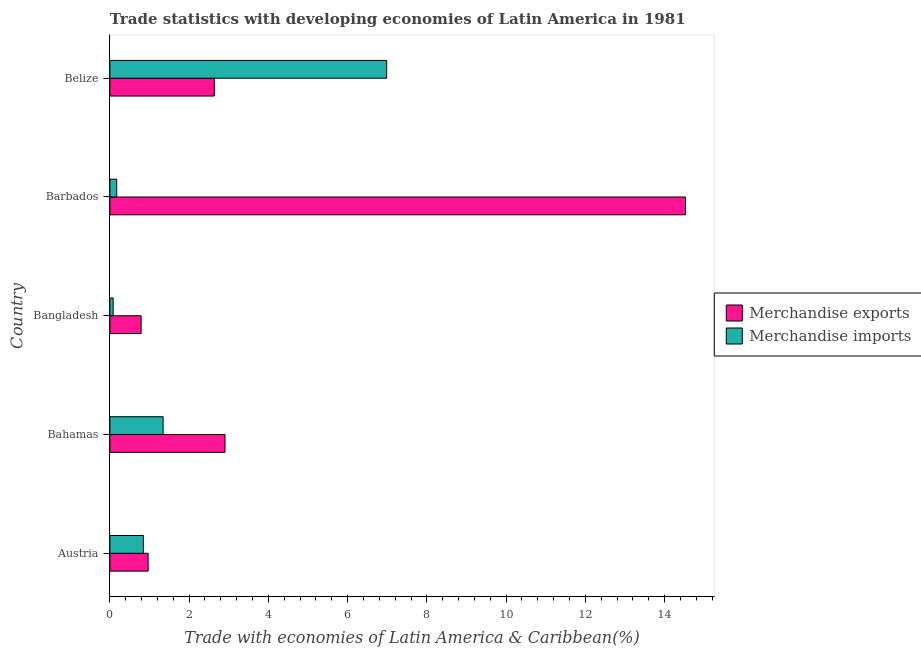How many groups of bars are there?
Make the answer very short. 5. How many bars are there on the 5th tick from the bottom?
Ensure brevity in your answer.  2. What is the label of the 1st group of bars from the top?
Provide a succinct answer. Belize. What is the merchandise imports in Bahamas?
Keep it short and to the point. 1.34. Across all countries, what is the maximum merchandise imports?
Offer a very short reply. 6.99. Across all countries, what is the minimum merchandise exports?
Keep it short and to the point. 0.79. In which country was the merchandise exports maximum?
Offer a very short reply. Barbados. In which country was the merchandise imports minimum?
Give a very brief answer. Bangladesh. What is the total merchandise exports in the graph?
Your answer should be compact. 21.82. What is the difference between the merchandise imports in Bahamas and that in Barbados?
Your answer should be very brief. 1.17. What is the difference between the merchandise exports in Bahamas and the merchandise imports in Barbados?
Provide a short and direct response. 2.73. What is the average merchandise exports per country?
Make the answer very short. 4.37. What is the difference between the merchandise exports and merchandise imports in Bangladesh?
Make the answer very short. 0.71. What is the ratio of the merchandise imports in Austria to that in Bangladesh?
Give a very brief answer. 10.26. What is the difference between the highest and the second highest merchandise exports?
Provide a short and direct response. 11.62. What is the difference between the highest and the lowest merchandise exports?
Your response must be concise. 13.74. Are all the bars in the graph horizontal?
Your answer should be compact. Yes. What is the difference between two consecutive major ticks on the X-axis?
Offer a terse response. 2. How many legend labels are there?
Keep it short and to the point. 2. What is the title of the graph?
Offer a terse response. Trade statistics with developing economies of Latin America in 1981. What is the label or title of the X-axis?
Your response must be concise. Trade with economies of Latin America & Caribbean(%). What is the label or title of the Y-axis?
Keep it short and to the point. Country. What is the Trade with economies of Latin America & Caribbean(%) of Merchandise exports in Austria?
Give a very brief answer. 0.97. What is the Trade with economies of Latin America & Caribbean(%) of Merchandise imports in Austria?
Your answer should be compact. 0.85. What is the Trade with economies of Latin America & Caribbean(%) in Merchandise exports in Bahamas?
Your answer should be compact. 2.91. What is the Trade with economies of Latin America & Caribbean(%) of Merchandise imports in Bahamas?
Your answer should be very brief. 1.34. What is the Trade with economies of Latin America & Caribbean(%) of Merchandise exports in Bangladesh?
Make the answer very short. 0.79. What is the Trade with economies of Latin America & Caribbean(%) of Merchandise imports in Bangladesh?
Give a very brief answer. 0.08. What is the Trade with economies of Latin America & Caribbean(%) of Merchandise exports in Barbados?
Your answer should be compact. 14.53. What is the Trade with economies of Latin America & Caribbean(%) in Merchandise imports in Barbados?
Provide a succinct answer. 0.17. What is the Trade with economies of Latin America & Caribbean(%) of Merchandise exports in Belize?
Keep it short and to the point. 2.63. What is the Trade with economies of Latin America & Caribbean(%) in Merchandise imports in Belize?
Offer a very short reply. 6.99. Across all countries, what is the maximum Trade with economies of Latin America & Caribbean(%) of Merchandise exports?
Offer a terse response. 14.53. Across all countries, what is the maximum Trade with economies of Latin America & Caribbean(%) in Merchandise imports?
Keep it short and to the point. 6.99. Across all countries, what is the minimum Trade with economies of Latin America & Caribbean(%) of Merchandise exports?
Give a very brief answer. 0.79. Across all countries, what is the minimum Trade with economies of Latin America & Caribbean(%) of Merchandise imports?
Make the answer very short. 0.08. What is the total Trade with economies of Latin America & Caribbean(%) in Merchandise exports in the graph?
Offer a very short reply. 21.82. What is the total Trade with economies of Latin America & Caribbean(%) of Merchandise imports in the graph?
Provide a short and direct response. 9.43. What is the difference between the Trade with economies of Latin America & Caribbean(%) in Merchandise exports in Austria and that in Bahamas?
Give a very brief answer. -1.94. What is the difference between the Trade with economies of Latin America & Caribbean(%) in Merchandise imports in Austria and that in Bahamas?
Give a very brief answer. -0.5. What is the difference between the Trade with economies of Latin America & Caribbean(%) of Merchandise exports in Austria and that in Bangladesh?
Make the answer very short. 0.18. What is the difference between the Trade with economies of Latin America & Caribbean(%) in Merchandise imports in Austria and that in Bangladesh?
Keep it short and to the point. 0.76. What is the difference between the Trade with economies of Latin America & Caribbean(%) of Merchandise exports in Austria and that in Barbados?
Keep it short and to the point. -13.56. What is the difference between the Trade with economies of Latin America & Caribbean(%) of Merchandise imports in Austria and that in Barbados?
Offer a terse response. 0.67. What is the difference between the Trade with economies of Latin America & Caribbean(%) in Merchandise exports in Austria and that in Belize?
Your response must be concise. -1.67. What is the difference between the Trade with economies of Latin America & Caribbean(%) in Merchandise imports in Austria and that in Belize?
Offer a very short reply. -6.14. What is the difference between the Trade with economies of Latin America & Caribbean(%) of Merchandise exports in Bahamas and that in Bangladesh?
Offer a terse response. 2.12. What is the difference between the Trade with economies of Latin America & Caribbean(%) of Merchandise imports in Bahamas and that in Bangladesh?
Give a very brief answer. 1.26. What is the difference between the Trade with economies of Latin America & Caribbean(%) of Merchandise exports in Bahamas and that in Barbados?
Keep it short and to the point. -11.62. What is the difference between the Trade with economies of Latin America & Caribbean(%) of Merchandise imports in Bahamas and that in Barbados?
Provide a succinct answer. 1.17. What is the difference between the Trade with economies of Latin America & Caribbean(%) of Merchandise exports in Bahamas and that in Belize?
Offer a very short reply. 0.27. What is the difference between the Trade with economies of Latin America & Caribbean(%) of Merchandise imports in Bahamas and that in Belize?
Keep it short and to the point. -5.64. What is the difference between the Trade with economies of Latin America & Caribbean(%) of Merchandise exports in Bangladesh and that in Barbados?
Provide a short and direct response. -13.74. What is the difference between the Trade with economies of Latin America & Caribbean(%) of Merchandise imports in Bangladesh and that in Barbados?
Your answer should be compact. -0.09. What is the difference between the Trade with economies of Latin America & Caribbean(%) of Merchandise exports in Bangladesh and that in Belize?
Offer a very short reply. -1.85. What is the difference between the Trade with economies of Latin America & Caribbean(%) in Merchandise imports in Bangladesh and that in Belize?
Provide a succinct answer. -6.9. What is the difference between the Trade with economies of Latin America & Caribbean(%) in Merchandise exports in Barbados and that in Belize?
Your answer should be compact. 11.89. What is the difference between the Trade with economies of Latin America & Caribbean(%) in Merchandise imports in Barbados and that in Belize?
Offer a very short reply. -6.81. What is the difference between the Trade with economies of Latin America & Caribbean(%) of Merchandise exports in Austria and the Trade with economies of Latin America & Caribbean(%) of Merchandise imports in Bahamas?
Provide a short and direct response. -0.38. What is the difference between the Trade with economies of Latin America & Caribbean(%) of Merchandise exports in Austria and the Trade with economies of Latin America & Caribbean(%) of Merchandise imports in Bangladesh?
Provide a succinct answer. 0.88. What is the difference between the Trade with economies of Latin America & Caribbean(%) of Merchandise exports in Austria and the Trade with economies of Latin America & Caribbean(%) of Merchandise imports in Barbados?
Offer a terse response. 0.79. What is the difference between the Trade with economies of Latin America & Caribbean(%) of Merchandise exports in Austria and the Trade with economies of Latin America & Caribbean(%) of Merchandise imports in Belize?
Keep it short and to the point. -6.02. What is the difference between the Trade with economies of Latin America & Caribbean(%) of Merchandise exports in Bahamas and the Trade with economies of Latin America & Caribbean(%) of Merchandise imports in Bangladesh?
Keep it short and to the point. 2.82. What is the difference between the Trade with economies of Latin America & Caribbean(%) in Merchandise exports in Bahamas and the Trade with economies of Latin America & Caribbean(%) in Merchandise imports in Barbados?
Ensure brevity in your answer.  2.73. What is the difference between the Trade with economies of Latin America & Caribbean(%) in Merchandise exports in Bahamas and the Trade with economies of Latin America & Caribbean(%) in Merchandise imports in Belize?
Offer a very short reply. -4.08. What is the difference between the Trade with economies of Latin America & Caribbean(%) in Merchandise exports in Bangladesh and the Trade with economies of Latin America & Caribbean(%) in Merchandise imports in Barbados?
Offer a terse response. 0.62. What is the difference between the Trade with economies of Latin America & Caribbean(%) of Merchandise exports in Bangladesh and the Trade with economies of Latin America & Caribbean(%) of Merchandise imports in Belize?
Offer a terse response. -6.2. What is the difference between the Trade with economies of Latin America & Caribbean(%) of Merchandise exports in Barbados and the Trade with economies of Latin America & Caribbean(%) of Merchandise imports in Belize?
Provide a succinct answer. 7.54. What is the average Trade with economies of Latin America & Caribbean(%) in Merchandise exports per country?
Offer a terse response. 4.36. What is the average Trade with economies of Latin America & Caribbean(%) of Merchandise imports per country?
Offer a terse response. 1.89. What is the difference between the Trade with economies of Latin America & Caribbean(%) of Merchandise exports and Trade with economies of Latin America & Caribbean(%) of Merchandise imports in Austria?
Your answer should be very brief. 0.12. What is the difference between the Trade with economies of Latin America & Caribbean(%) in Merchandise exports and Trade with economies of Latin America & Caribbean(%) in Merchandise imports in Bahamas?
Offer a terse response. 1.56. What is the difference between the Trade with economies of Latin America & Caribbean(%) of Merchandise exports and Trade with economies of Latin America & Caribbean(%) of Merchandise imports in Bangladesh?
Give a very brief answer. 0.71. What is the difference between the Trade with economies of Latin America & Caribbean(%) of Merchandise exports and Trade with economies of Latin America & Caribbean(%) of Merchandise imports in Barbados?
Provide a short and direct response. 14.36. What is the difference between the Trade with economies of Latin America & Caribbean(%) in Merchandise exports and Trade with economies of Latin America & Caribbean(%) in Merchandise imports in Belize?
Ensure brevity in your answer.  -4.35. What is the ratio of the Trade with economies of Latin America & Caribbean(%) in Merchandise exports in Austria to that in Bahamas?
Make the answer very short. 0.33. What is the ratio of the Trade with economies of Latin America & Caribbean(%) in Merchandise imports in Austria to that in Bahamas?
Your response must be concise. 0.63. What is the ratio of the Trade with economies of Latin America & Caribbean(%) of Merchandise exports in Austria to that in Bangladesh?
Your answer should be compact. 1.22. What is the ratio of the Trade with economies of Latin America & Caribbean(%) in Merchandise imports in Austria to that in Bangladesh?
Give a very brief answer. 10.26. What is the ratio of the Trade with economies of Latin America & Caribbean(%) in Merchandise exports in Austria to that in Barbados?
Give a very brief answer. 0.07. What is the ratio of the Trade with economies of Latin America & Caribbean(%) in Merchandise imports in Austria to that in Barbados?
Make the answer very short. 4.91. What is the ratio of the Trade with economies of Latin America & Caribbean(%) of Merchandise exports in Austria to that in Belize?
Your answer should be compact. 0.37. What is the ratio of the Trade with economies of Latin America & Caribbean(%) of Merchandise imports in Austria to that in Belize?
Give a very brief answer. 0.12. What is the ratio of the Trade with economies of Latin America & Caribbean(%) in Merchandise exports in Bahamas to that in Bangladesh?
Provide a succinct answer. 3.69. What is the ratio of the Trade with economies of Latin America & Caribbean(%) in Merchandise imports in Bahamas to that in Bangladesh?
Offer a very short reply. 16.29. What is the ratio of the Trade with economies of Latin America & Caribbean(%) in Merchandise exports in Bahamas to that in Barbados?
Give a very brief answer. 0.2. What is the ratio of the Trade with economies of Latin America & Caribbean(%) of Merchandise imports in Bahamas to that in Barbados?
Your answer should be very brief. 7.79. What is the ratio of the Trade with economies of Latin America & Caribbean(%) in Merchandise exports in Bahamas to that in Belize?
Your answer should be very brief. 1.1. What is the ratio of the Trade with economies of Latin America & Caribbean(%) in Merchandise imports in Bahamas to that in Belize?
Offer a terse response. 0.19. What is the ratio of the Trade with economies of Latin America & Caribbean(%) of Merchandise exports in Bangladesh to that in Barbados?
Offer a terse response. 0.05. What is the ratio of the Trade with economies of Latin America & Caribbean(%) of Merchandise imports in Bangladesh to that in Barbados?
Make the answer very short. 0.48. What is the ratio of the Trade with economies of Latin America & Caribbean(%) in Merchandise exports in Bangladesh to that in Belize?
Keep it short and to the point. 0.3. What is the ratio of the Trade with economies of Latin America & Caribbean(%) of Merchandise imports in Bangladesh to that in Belize?
Provide a succinct answer. 0.01. What is the ratio of the Trade with economies of Latin America & Caribbean(%) in Merchandise exports in Barbados to that in Belize?
Provide a succinct answer. 5.51. What is the ratio of the Trade with economies of Latin America & Caribbean(%) in Merchandise imports in Barbados to that in Belize?
Ensure brevity in your answer.  0.02. What is the difference between the highest and the second highest Trade with economies of Latin America & Caribbean(%) in Merchandise exports?
Your answer should be very brief. 11.62. What is the difference between the highest and the second highest Trade with economies of Latin America & Caribbean(%) of Merchandise imports?
Provide a short and direct response. 5.64. What is the difference between the highest and the lowest Trade with economies of Latin America & Caribbean(%) of Merchandise exports?
Make the answer very short. 13.74. What is the difference between the highest and the lowest Trade with economies of Latin America & Caribbean(%) of Merchandise imports?
Provide a succinct answer. 6.9. 